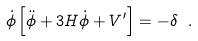<formula> <loc_0><loc_0><loc_500><loc_500>\dot { \phi } \left [ \ddot { \phi } + 3 H \dot { \phi } + V ^ { \prime } \right ] = - \delta \ .</formula> 